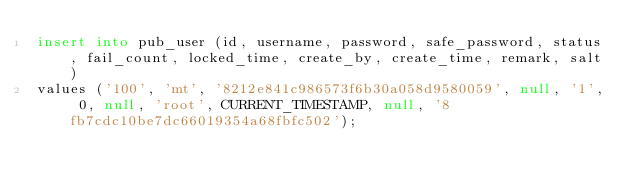<code> <loc_0><loc_0><loc_500><loc_500><_SQL_>insert into pub_user (id, username, password, safe_password, status, fail_count, locked_time, create_by, create_time, remark, salt)
values ('100', 'mt', '8212e841c986573f6b30a058d9580059', null, '1', 0, null, 'root', CURRENT_TIMESTAMP, null, '8fb7cdc10be7dc66019354a68fbfc502');

</code> 